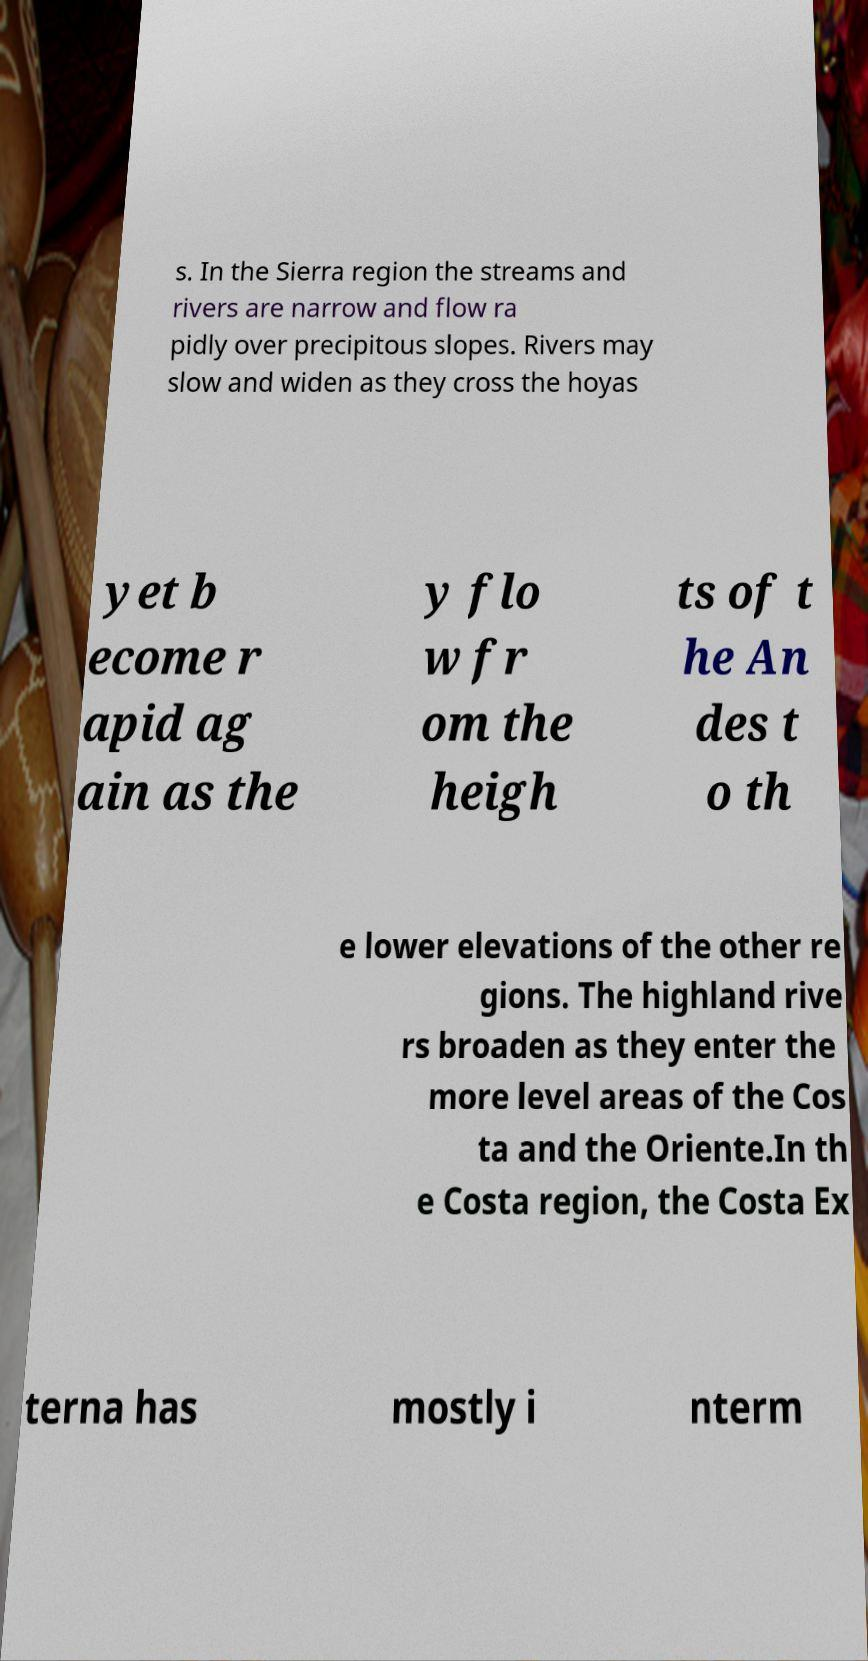What messages or text are displayed in this image? I need them in a readable, typed format. s. In the Sierra region the streams and rivers are narrow and flow ra pidly over precipitous slopes. Rivers may slow and widen as they cross the hoyas yet b ecome r apid ag ain as the y flo w fr om the heigh ts of t he An des t o th e lower elevations of the other re gions. The highland rive rs broaden as they enter the more level areas of the Cos ta and the Oriente.In th e Costa region, the Costa Ex terna has mostly i nterm 